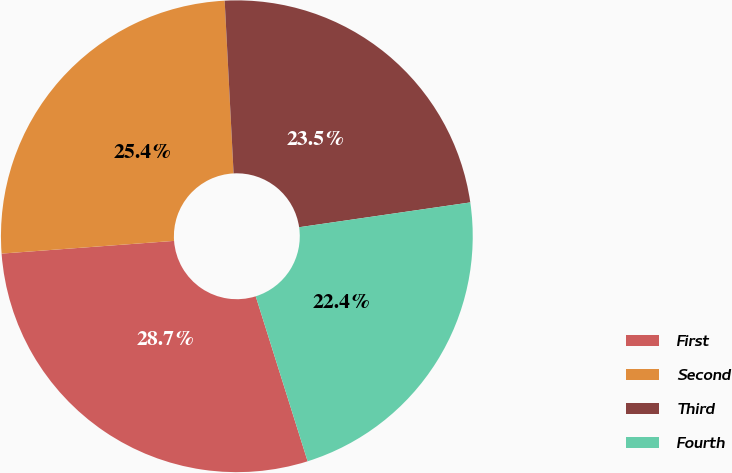Convert chart. <chart><loc_0><loc_0><loc_500><loc_500><pie_chart><fcel>First<fcel>Second<fcel>Third<fcel>Fourth<nl><fcel>28.68%<fcel>25.35%<fcel>23.53%<fcel>22.44%<nl></chart> 